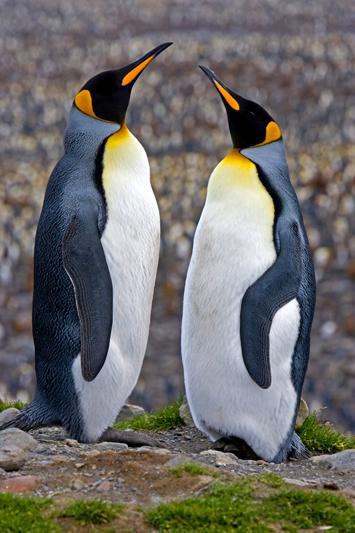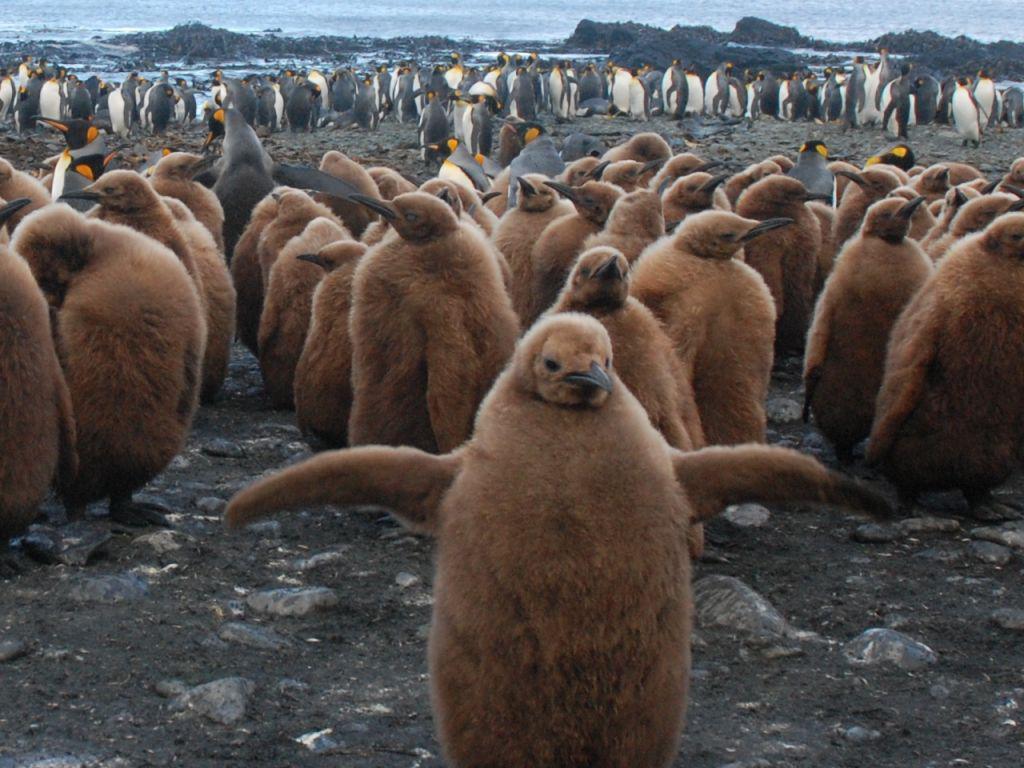The first image is the image on the left, the second image is the image on the right. For the images shown, is this caption "There are two penguins in the left image" true? Answer yes or no. Yes. The first image is the image on the left, the second image is the image on the right. Assess this claim about the two images: "One image shows just two penguins side-by-side, with faces turned inward.". Correct or not? Answer yes or no. Yes. 